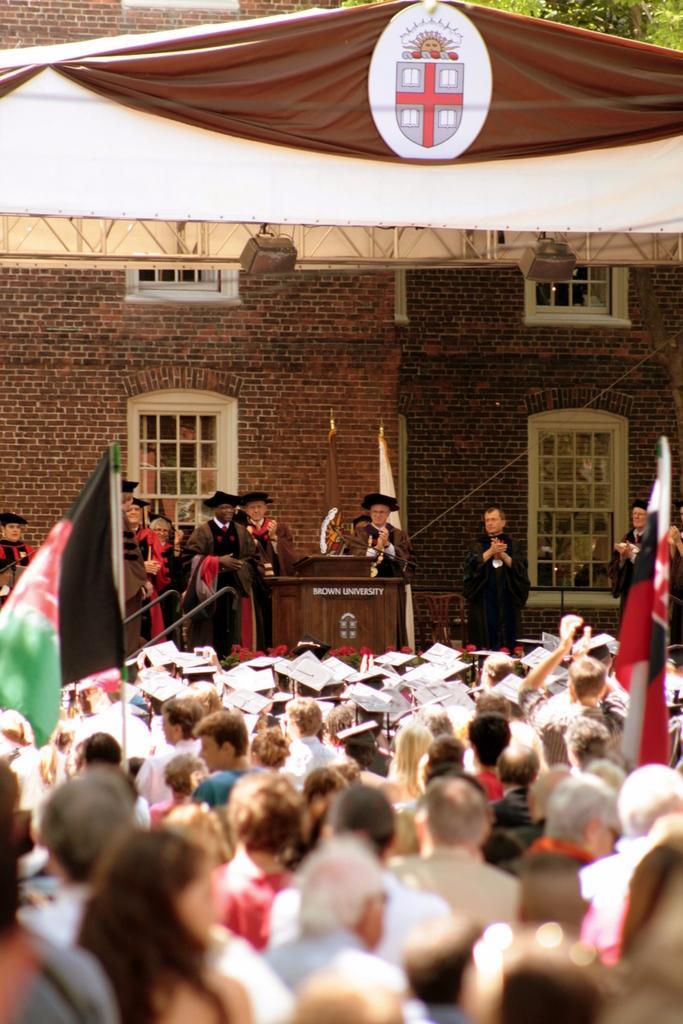Describe this image in one or two sentences. In this picture I can see group of people among the some are standing. I can also see a podium and flags. In the background building which has windows. I can also see tree. 